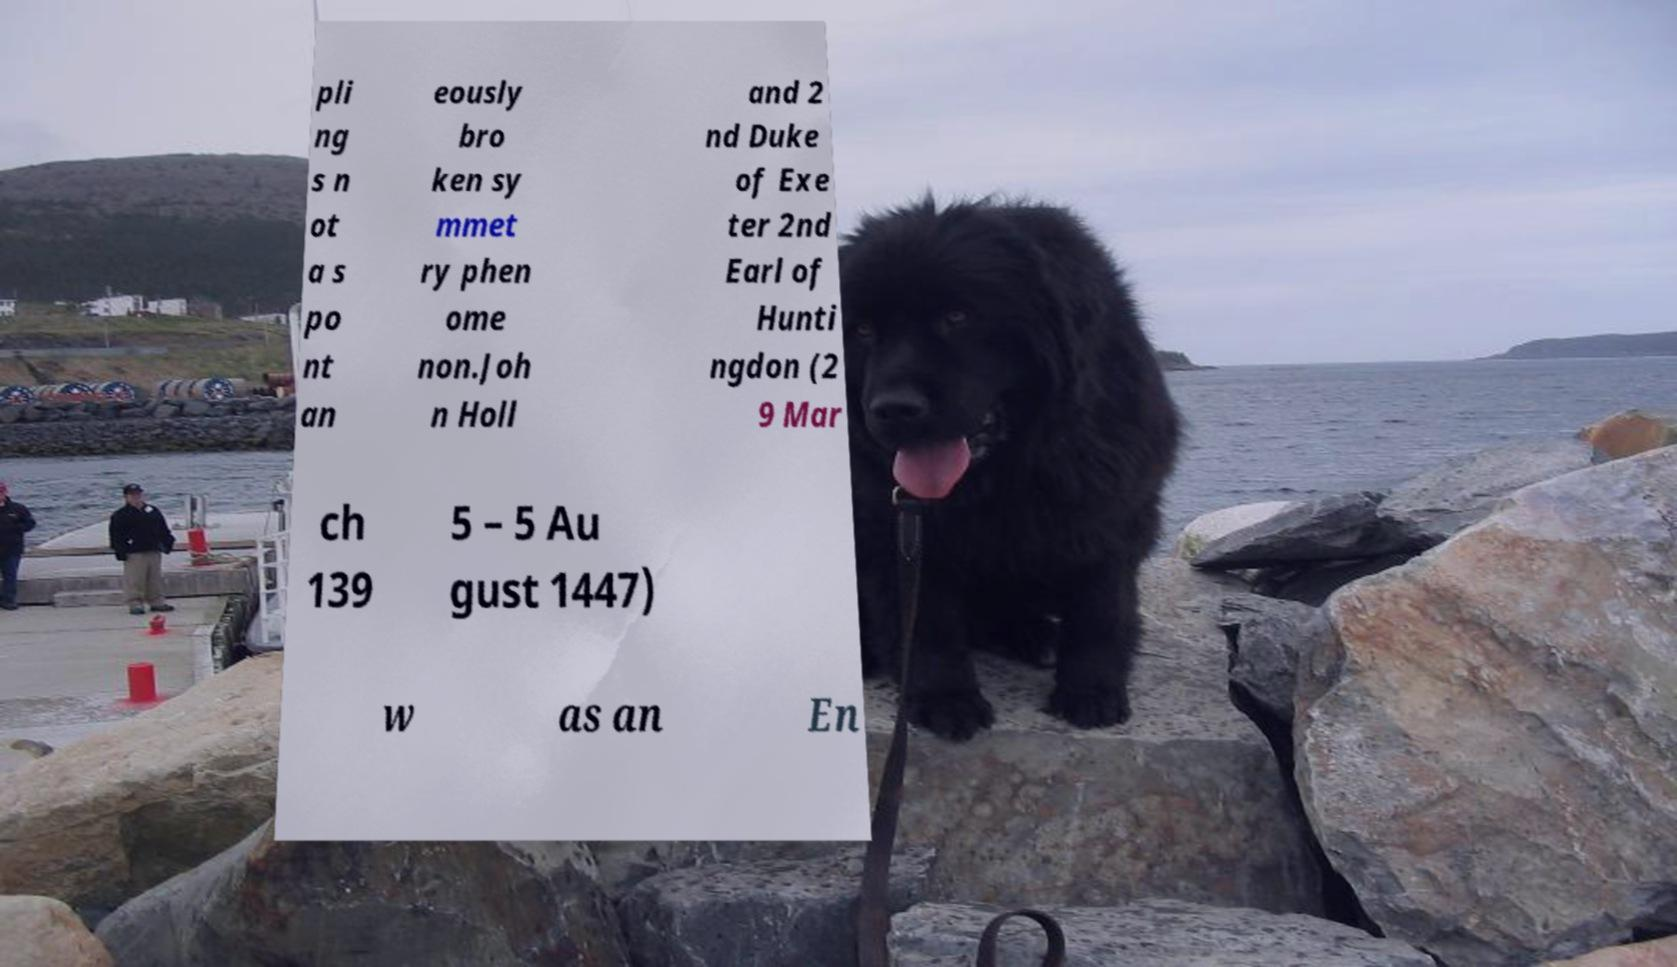For documentation purposes, I need the text within this image transcribed. Could you provide that? pli ng s n ot a s po nt an eously bro ken sy mmet ry phen ome non.Joh n Holl and 2 nd Duke of Exe ter 2nd Earl of Hunti ngdon (2 9 Mar ch 139 5 – 5 Au gust 1447) w as an En 